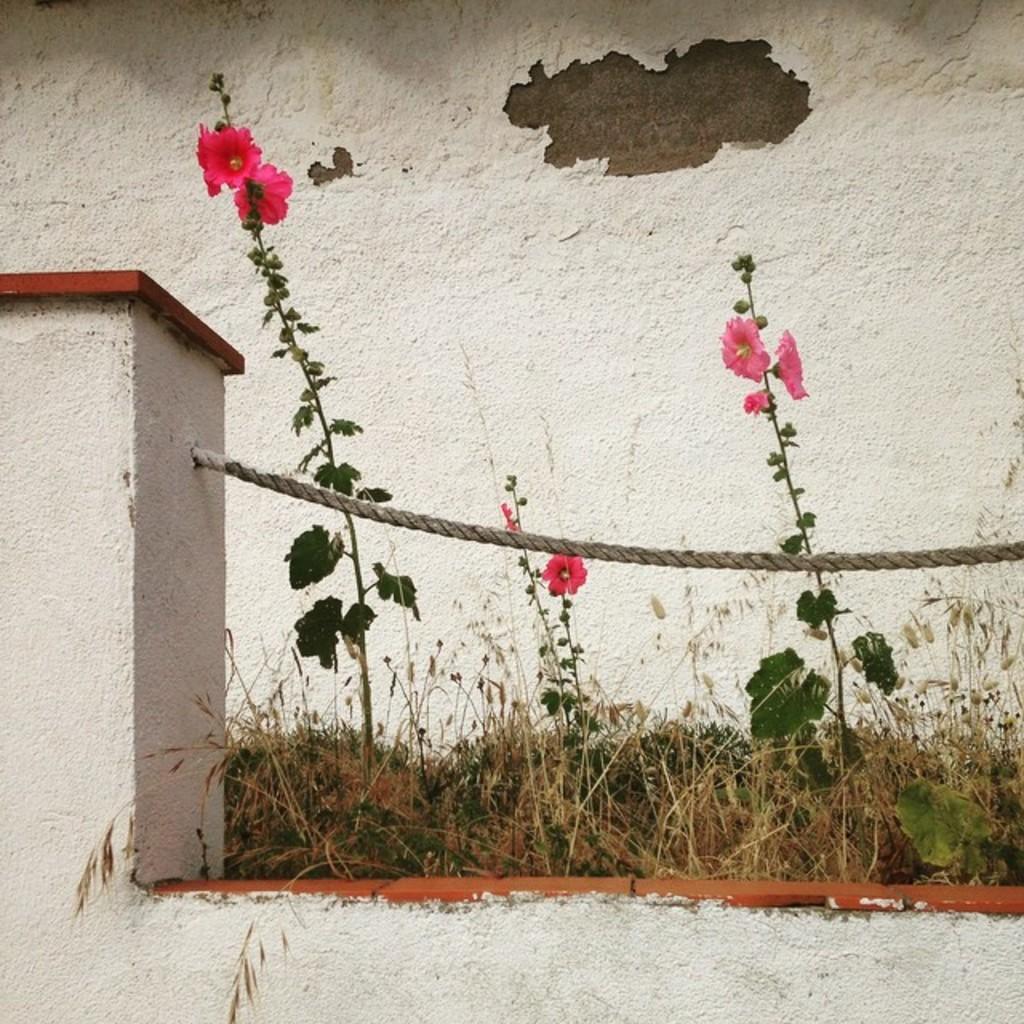Can you describe this image briefly? In this image I can see few red and pink color flowers and plants. I can see a white wall,pillar,rope and dry grass. 